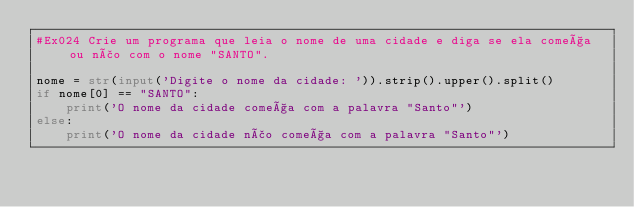Convert code to text. <code><loc_0><loc_0><loc_500><loc_500><_Python_>#Ex024 Crie um programa que leia o nome de uma cidade e diga se ela começa ou não com o nome "SANTO".

nome = str(input('Digite o nome da cidade: ')).strip().upper().split()
if nome[0] == "SANTO":
    print('O nome da cidade começa com a palavra "Santo"')
else:
    print('O nome da cidade não começa com a palavra "Santo"')




</code> 